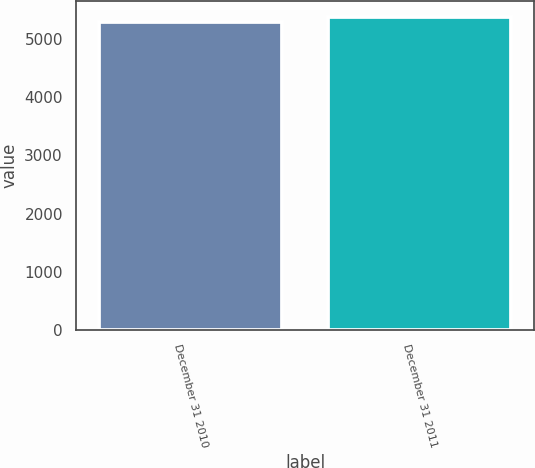Convert chart. <chart><loc_0><loc_0><loc_500><loc_500><bar_chart><fcel>December 31 2010<fcel>December 31 2011<nl><fcel>5302<fcel>5394<nl></chart> 